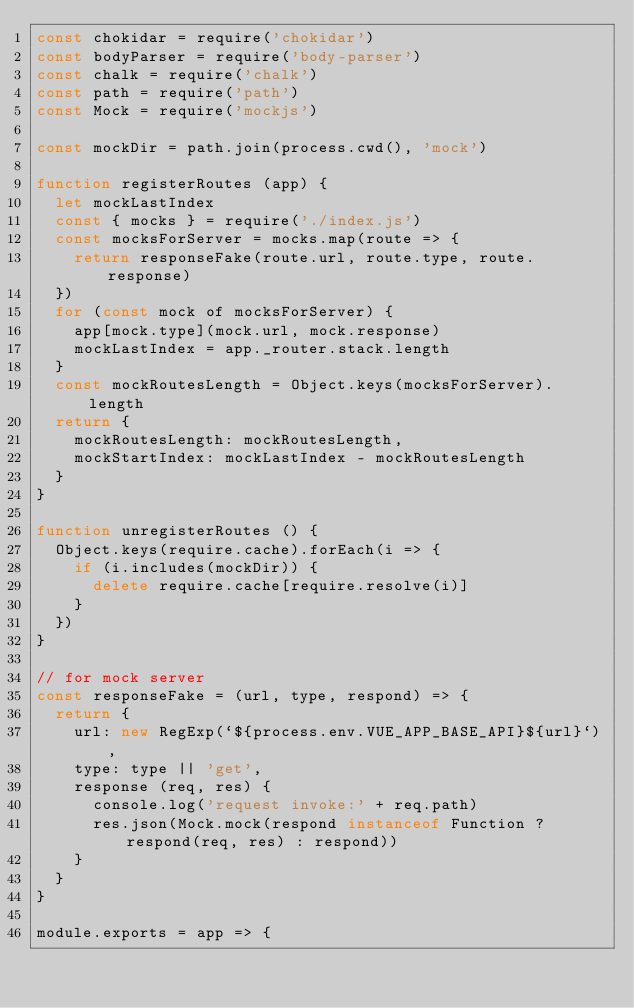Convert code to text. <code><loc_0><loc_0><loc_500><loc_500><_JavaScript_>const chokidar = require('chokidar')
const bodyParser = require('body-parser')
const chalk = require('chalk')
const path = require('path')
const Mock = require('mockjs')

const mockDir = path.join(process.cwd(), 'mock')

function registerRoutes (app) {
  let mockLastIndex
  const { mocks } = require('./index.js')
  const mocksForServer = mocks.map(route => {
    return responseFake(route.url, route.type, route.response)
  })
  for (const mock of mocksForServer) {
    app[mock.type](mock.url, mock.response)
    mockLastIndex = app._router.stack.length
  }
  const mockRoutesLength = Object.keys(mocksForServer).length
  return {
    mockRoutesLength: mockRoutesLength,
    mockStartIndex: mockLastIndex - mockRoutesLength
  }
}

function unregisterRoutes () {
  Object.keys(require.cache).forEach(i => {
    if (i.includes(mockDir)) {
      delete require.cache[require.resolve(i)]
    }
  })
}

// for mock server
const responseFake = (url, type, respond) => {
  return {
    url: new RegExp(`${process.env.VUE_APP_BASE_API}${url}`),
    type: type || 'get',
    response (req, res) {
      console.log('request invoke:' + req.path)
      res.json(Mock.mock(respond instanceof Function ? respond(req, res) : respond))
    }
  }
}

module.exports = app => {</code> 